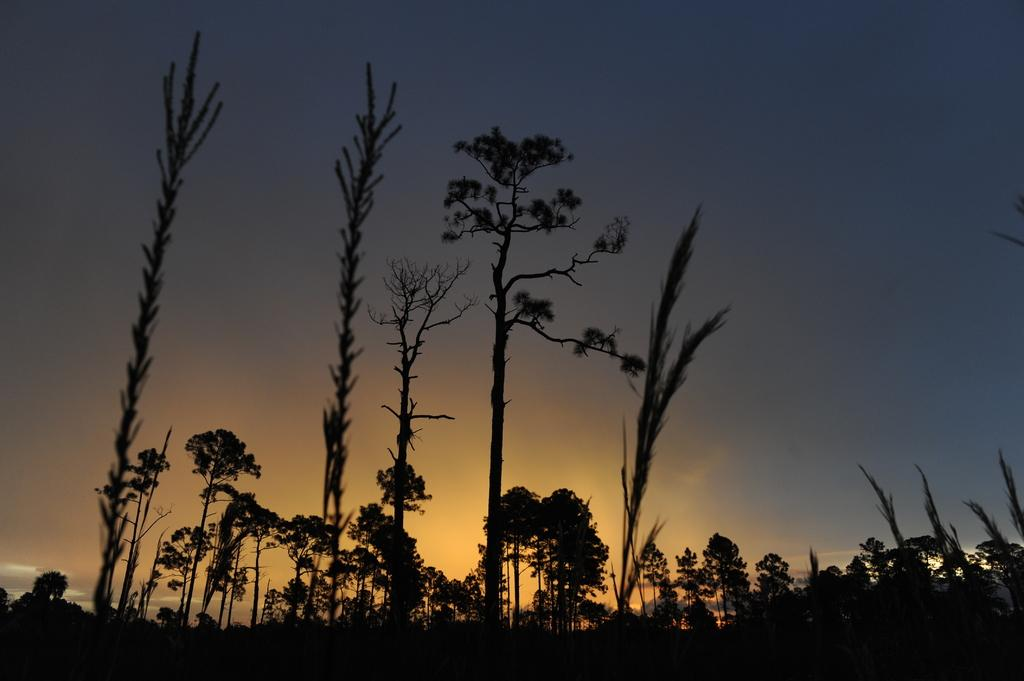What type of vegetation can be seen in the image? There are trees and plants in the image. What time of day is depicted in the image? The image depicts a sunset. What scent can be detected from the plants in the image? There is no information about the scent of the plants in the image, as it is a visual representation only. 